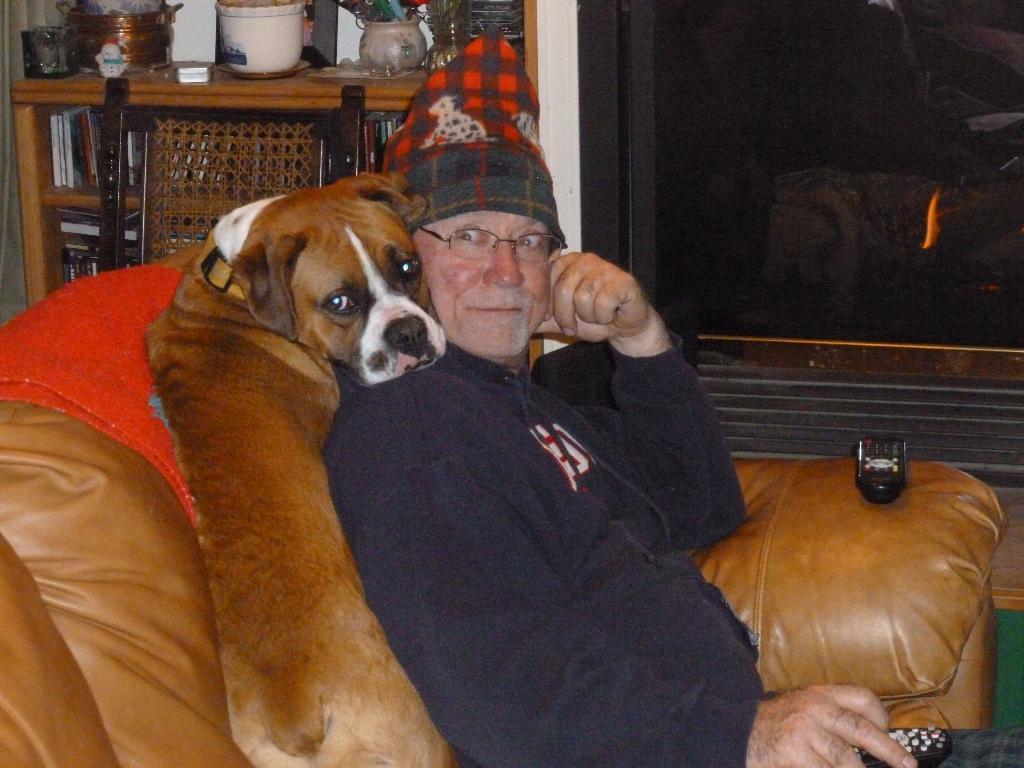Describe this image in one or two sentences. In this image I can see a man and a dog on a sofa. I can also see he is holding a remote and wearing a specs and a cap. In the background I can see a chair and few utensils. 